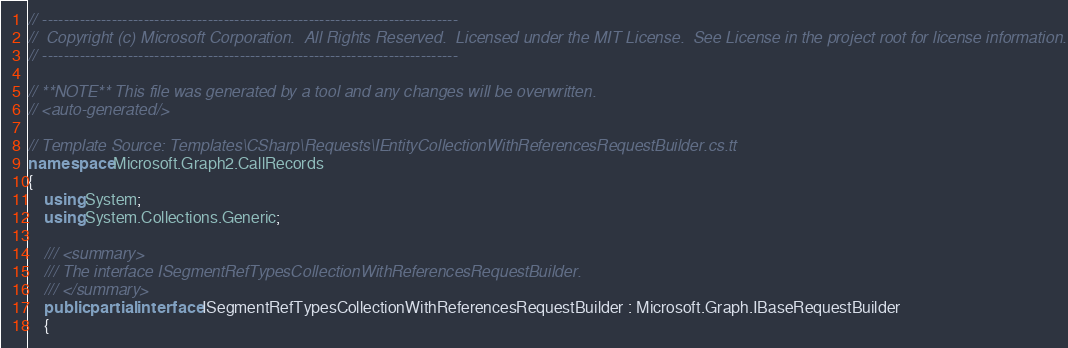<code> <loc_0><loc_0><loc_500><loc_500><_C#_>// ------------------------------------------------------------------------------
//  Copyright (c) Microsoft Corporation.  All Rights Reserved.  Licensed under the MIT License.  See License in the project root for license information.
// ------------------------------------------------------------------------------

// **NOTE** This file was generated by a tool and any changes will be overwritten.
// <auto-generated/>

// Template Source: Templates\CSharp\Requests\IEntityCollectionWithReferencesRequestBuilder.cs.tt
namespace Microsoft.Graph2.CallRecords
{
    using System;
    using System.Collections.Generic;

    /// <summary>
    /// The interface ISegmentRefTypesCollectionWithReferencesRequestBuilder.
    /// </summary>
    public partial interface ISegmentRefTypesCollectionWithReferencesRequestBuilder : Microsoft.Graph.IBaseRequestBuilder
    {</code> 